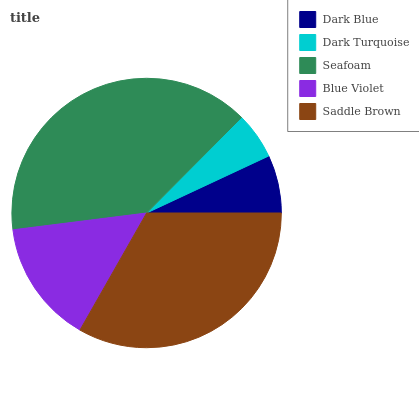Is Dark Turquoise the minimum?
Answer yes or no. Yes. Is Seafoam the maximum?
Answer yes or no. Yes. Is Seafoam the minimum?
Answer yes or no. No. Is Dark Turquoise the maximum?
Answer yes or no. No. Is Seafoam greater than Dark Turquoise?
Answer yes or no. Yes. Is Dark Turquoise less than Seafoam?
Answer yes or no. Yes. Is Dark Turquoise greater than Seafoam?
Answer yes or no. No. Is Seafoam less than Dark Turquoise?
Answer yes or no. No. Is Blue Violet the high median?
Answer yes or no. Yes. Is Blue Violet the low median?
Answer yes or no. Yes. Is Seafoam the high median?
Answer yes or no. No. Is Dark Blue the low median?
Answer yes or no. No. 